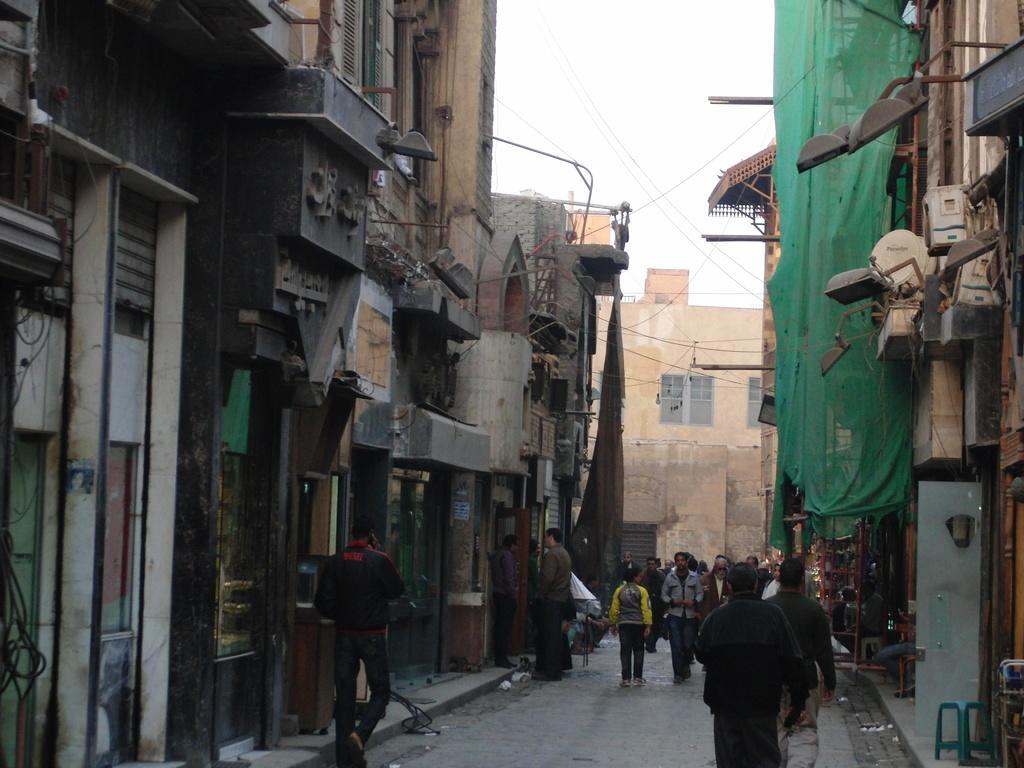Can you describe this image briefly? This is a street. In this many people are standing and walking. On the right side there are buildings. On the roadside there is a stool. And the building is having a bulb. On the left side also there are buildings. 